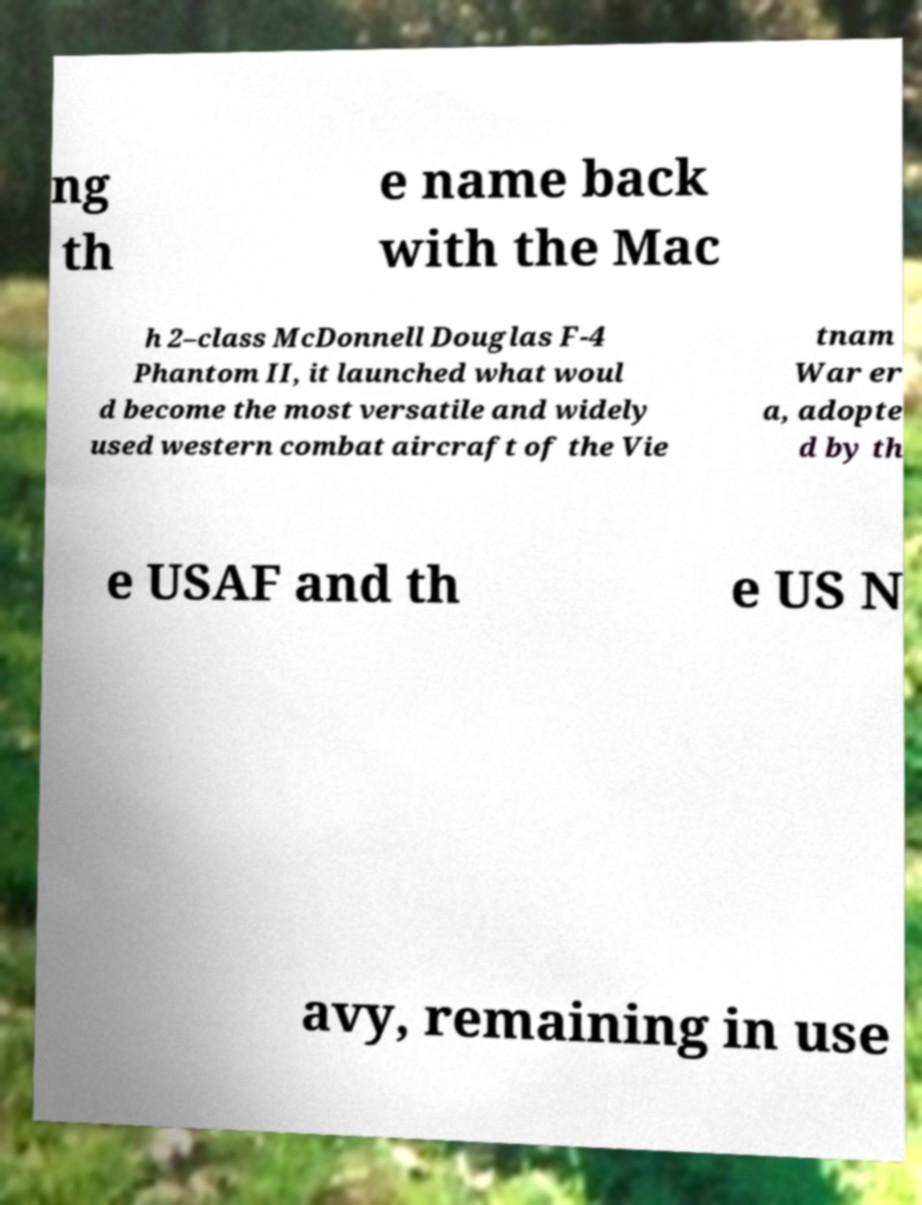Can you accurately transcribe the text from the provided image for me? ng th e name back with the Mac h 2–class McDonnell Douglas F-4 Phantom II, it launched what woul d become the most versatile and widely used western combat aircraft of the Vie tnam War er a, adopte d by th e USAF and th e US N avy, remaining in use 